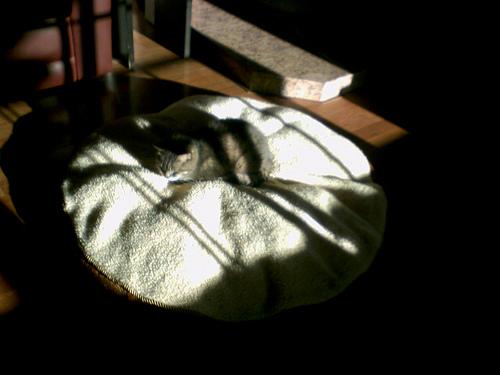What is the cat sitting on?
Write a very short answer. Pillow. What color is the kitten?
Keep it brief. Gray. Shadows are cast?
Write a very short answer. Yes. 